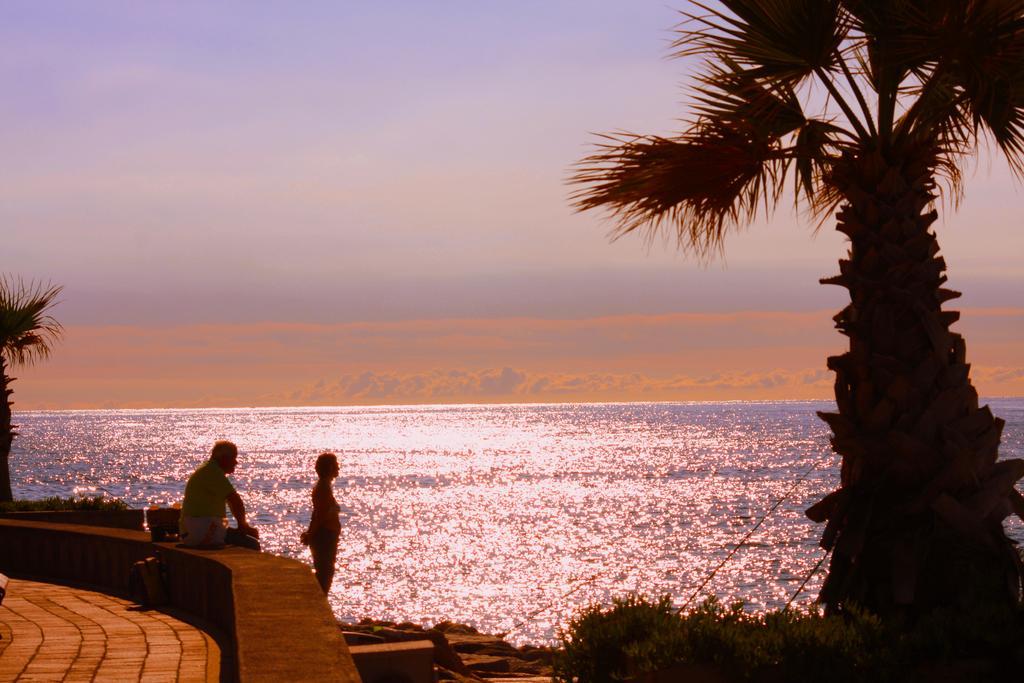Please provide a concise description of this image. In this image we can see the sea, the two big trees, some bushes, some rocks, some objects on the surface, one man sitting on the wall, one footpath, one woman is standing near to the sea and at the top there is blue, reddish sky. 